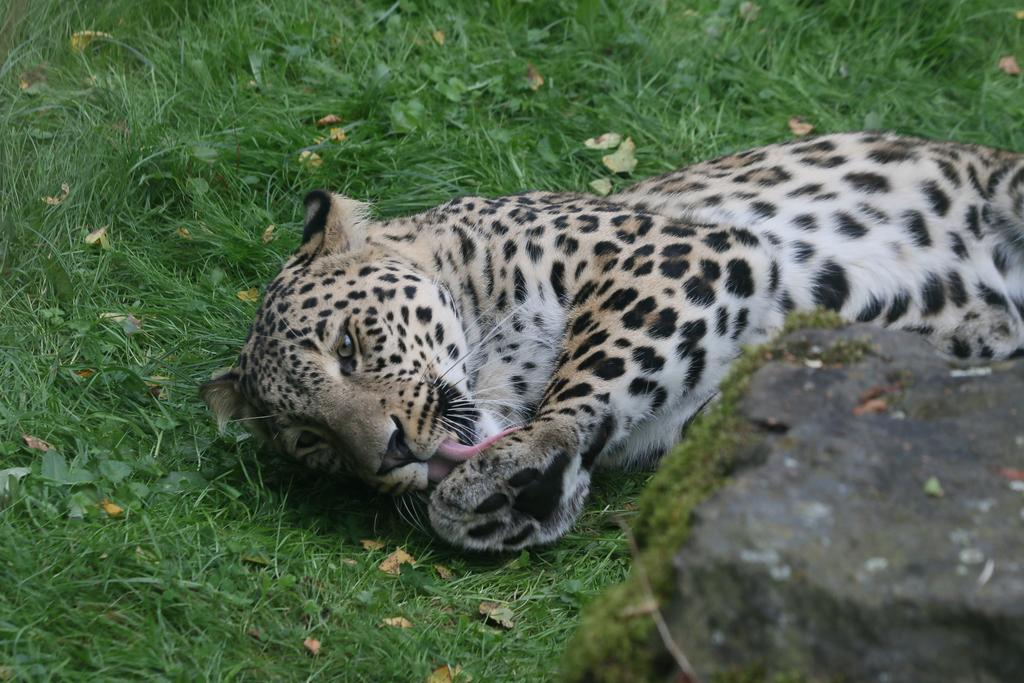What type of animal is in the image? There is a cheetah in the image. What is the cheetah doing in the image? The cheetah is sleeping in the image. What is the cheetah resting on in the image? The cheetah is on the grass in the image. What other object can be seen in the image? There is a stone in the image. Where is the stone located in relation to the cheetah? The stone is beside the cheetah in the image. Can you tell me how many holes are visible in the image? There are no holes visible in the image. What type of grandmother is sitting next to the cheetah in the image? There is no grandmother present in the image. 